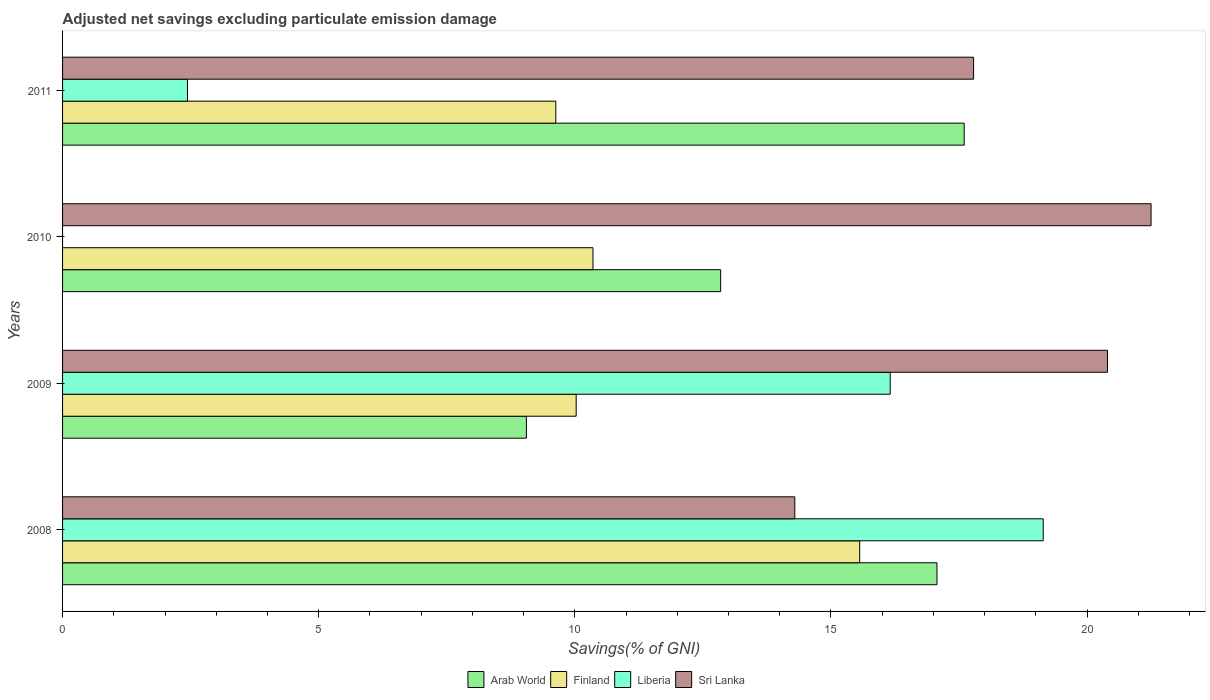Are the number of bars per tick equal to the number of legend labels?
Your response must be concise. No. Are the number of bars on each tick of the Y-axis equal?
Offer a very short reply. No. How many bars are there on the 4th tick from the top?
Offer a terse response. 4. What is the label of the 4th group of bars from the top?
Keep it short and to the point. 2008. What is the adjusted net savings in Arab World in 2011?
Offer a terse response. 17.6. Across all years, what is the maximum adjusted net savings in Arab World?
Make the answer very short. 17.6. In which year was the adjusted net savings in Liberia maximum?
Ensure brevity in your answer.  2008. What is the total adjusted net savings in Finland in the graph?
Make the answer very short. 45.57. What is the difference between the adjusted net savings in Arab World in 2009 and that in 2011?
Your answer should be compact. -8.55. What is the difference between the adjusted net savings in Arab World in 2010 and the adjusted net savings in Sri Lanka in 2008?
Your response must be concise. -1.45. What is the average adjusted net savings in Liberia per year?
Provide a short and direct response. 9.44. In the year 2010, what is the difference between the adjusted net savings in Finland and adjusted net savings in Sri Lanka?
Offer a terse response. -10.89. In how many years, is the adjusted net savings in Sri Lanka greater than 18 %?
Your answer should be compact. 2. What is the ratio of the adjusted net savings in Finland in 2008 to that in 2010?
Your answer should be very brief. 1.5. Is the difference between the adjusted net savings in Finland in 2008 and 2009 greater than the difference between the adjusted net savings in Sri Lanka in 2008 and 2009?
Your answer should be compact. Yes. What is the difference between the highest and the second highest adjusted net savings in Sri Lanka?
Provide a succinct answer. 0.85. What is the difference between the highest and the lowest adjusted net savings in Sri Lanka?
Provide a succinct answer. 6.96. In how many years, is the adjusted net savings in Liberia greater than the average adjusted net savings in Liberia taken over all years?
Give a very brief answer. 2. Is it the case that in every year, the sum of the adjusted net savings in Finland and adjusted net savings in Arab World is greater than the sum of adjusted net savings in Liberia and adjusted net savings in Sri Lanka?
Your answer should be very brief. No. Is it the case that in every year, the sum of the adjusted net savings in Arab World and adjusted net savings in Sri Lanka is greater than the adjusted net savings in Finland?
Provide a succinct answer. Yes. Are all the bars in the graph horizontal?
Provide a short and direct response. Yes. Are the values on the major ticks of X-axis written in scientific E-notation?
Your response must be concise. No. Does the graph contain any zero values?
Provide a short and direct response. Yes. How many legend labels are there?
Ensure brevity in your answer.  4. What is the title of the graph?
Your response must be concise. Adjusted net savings excluding particulate emission damage. Does "Tunisia" appear as one of the legend labels in the graph?
Give a very brief answer. No. What is the label or title of the X-axis?
Give a very brief answer. Savings(% of GNI). What is the label or title of the Y-axis?
Your answer should be compact. Years. What is the Savings(% of GNI) of Arab World in 2008?
Offer a very short reply. 17.07. What is the Savings(% of GNI) of Finland in 2008?
Make the answer very short. 15.56. What is the Savings(% of GNI) in Liberia in 2008?
Make the answer very short. 19.15. What is the Savings(% of GNI) of Sri Lanka in 2008?
Keep it short and to the point. 14.3. What is the Savings(% of GNI) in Arab World in 2009?
Give a very brief answer. 9.06. What is the Savings(% of GNI) of Finland in 2009?
Offer a very short reply. 10.03. What is the Savings(% of GNI) in Liberia in 2009?
Make the answer very short. 16.16. What is the Savings(% of GNI) in Sri Lanka in 2009?
Make the answer very short. 20.4. What is the Savings(% of GNI) of Arab World in 2010?
Your answer should be compact. 12.85. What is the Savings(% of GNI) of Finland in 2010?
Provide a succinct answer. 10.36. What is the Savings(% of GNI) of Sri Lanka in 2010?
Provide a succinct answer. 21.25. What is the Savings(% of GNI) of Arab World in 2011?
Provide a short and direct response. 17.6. What is the Savings(% of GNI) of Finland in 2011?
Your answer should be compact. 9.63. What is the Savings(% of GNI) of Liberia in 2011?
Provide a succinct answer. 2.44. What is the Savings(% of GNI) in Sri Lanka in 2011?
Your response must be concise. 17.79. Across all years, what is the maximum Savings(% of GNI) of Arab World?
Your response must be concise. 17.6. Across all years, what is the maximum Savings(% of GNI) in Finland?
Offer a very short reply. 15.56. Across all years, what is the maximum Savings(% of GNI) of Liberia?
Make the answer very short. 19.15. Across all years, what is the maximum Savings(% of GNI) in Sri Lanka?
Your answer should be compact. 21.25. Across all years, what is the minimum Savings(% of GNI) in Arab World?
Your response must be concise. 9.06. Across all years, what is the minimum Savings(% of GNI) of Finland?
Offer a terse response. 9.63. Across all years, what is the minimum Savings(% of GNI) in Liberia?
Keep it short and to the point. 0. Across all years, what is the minimum Savings(% of GNI) of Sri Lanka?
Your answer should be very brief. 14.3. What is the total Savings(% of GNI) in Arab World in the graph?
Make the answer very short. 56.58. What is the total Savings(% of GNI) in Finland in the graph?
Make the answer very short. 45.57. What is the total Savings(% of GNI) of Liberia in the graph?
Ensure brevity in your answer.  37.74. What is the total Savings(% of GNI) of Sri Lanka in the graph?
Ensure brevity in your answer.  73.73. What is the difference between the Savings(% of GNI) in Arab World in 2008 and that in 2009?
Provide a succinct answer. 8.02. What is the difference between the Savings(% of GNI) in Finland in 2008 and that in 2009?
Provide a short and direct response. 5.54. What is the difference between the Savings(% of GNI) of Liberia in 2008 and that in 2009?
Offer a very short reply. 2.99. What is the difference between the Savings(% of GNI) of Sri Lanka in 2008 and that in 2009?
Your answer should be compact. -6.1. What is the difference between the Savings(% of GNI) in Arab World in 2008 and that in 2010?
Your answer should be very brief. 4.22. What is the difference between the Savings(% of GNI) of Finland in 2008 and that in 2010?
Make the answer very short. 5.21. What is the difference between the Savings(% of GNI) in Sri Lanka in 2008 and that in 2010?
Provide a succinct answer. -6.96. What is the difference between the Savings(% of GNI) of Arab World in 2008 and that in 2011?
Give a very brief answer. -0.53. What is the difference between the Savings(% of GNI) of Finland in 2008 and that in 2011?
Your answer should be compact. 5.93. What is the difference between the Savings(% of GNI) of Liberia in 2008 and that in 2011?
Your response must be concise. 16.71. What is the difference between the Savings(% of GNI) in Sri Lanka in 2008 and that in 2011?
Provide a succinct answer. -3.49. What is the difference between the Savings(% of GNI) of Arab World in 2009 and that in 2010?
Give a very brief answer. -3.79. What is the difference between the Savings(% of GNI) in Finland in 2009 and that in 2010?
Your answer should be very brief. -0.33. What is the difference between the Savings(% of GNI) in Sri Lanka in 2009 and that in 2010?
Your response must be concise. -0.85. What is the difference between the Savings(% of GNI) of Arab World in 2009 and that in 2011?
Offer a terse response. -8.55. What is the difference between the Savings(% of GNI) in Finland in 2009 and that in 2011?
Keep it short and to the point. 0.4. What is the difference between the Savings(% of GNI) of Liberia in 2009 and that in 2011?
Ensure brevity in your answer.  13.72. What is the difference between the Savings(% of GNI) in Sri Lanka in 2009 and that in 2011?
Provide a short and direct response. 2.61. What is the difference between the Savings(% of GNI) in Arab World in 2010 and that in 2011?
Keep it short and to the point. -4.75. What is the difference between the Savings(% of GNI) in Finland in 2010 and that in 2011?
Your answer should be compact. 0.73. What is the difference between the Savings(% of GNI) in Sri Lanka in 2010 and that in 2011?
Keep it short and to the point. 3.47. What is the difference between the Savings(% of GNI) in Arab World in 2008 and the Savings(% of GNI) in Finland in 2009?
Ensure brevity in your answer.  7.04. What is the difference between the Savings(% of GNI) of Arab World in 2008 and the Savings(% of GNI) of Liberia in 2009?
Offer a very short reply. 0.91. What is the difference between the Savings(% of GNI) of Arab World in 2008 and the Savings(% of GNI) of Sri Lanka in 2009?
Offer a terse response. -3.33. What is the difference between the Savings(% of GNI) in Finland in 2008 and the Savings(% of GNI) in Liberia in 2009?
Offer a very short reply. -0.6. What is the difference between the Savings(% of GNI) of Finland in 2008 and the Savings(% of GNI) of Sri Lanka in 2009?
Offer a very short reply. -4.84. What is the difference between the Savings(% of GNI) in Liberia in 2008 and the Savings(% of GNI) in Sri Lanka in 2009?
Give a very brief answer. -1.25. What is the difference between the Savings(% of GNI) in Arab World in 2008 and the Savings(% of GNI) in Finland in 2010?
Provide a succinct answer. 6.72. What is the difference between the Savings(% of GNI) of Arab World in 2008 and the Savings(% of GNI) of Sri Lanka in 2010?
Offer a terse response. -4.18. What is the difference between the Savings(% of GNI) of Finland in 2008 and the Savings(% of GNI) of Sri Lanka in 2010?
Your response must be concise. -5.69. What is the difference between the Savings(% of GNI) in Liberia in 2008 and the Savings(% of GNI) in Sri Lanka in 2010?
Ensure brevity in your answer.  -2.11. What is the difference between the Savings(% of GNI) of Arab World in 2008 and the Savings(% of GNI) of Finland in 2011?
Your response must be concise. 7.44. What is the difference between the Savings(% of GNI) in Arab World in 2008 and the Savings(% of GNI) in Liberia in 2011?
Offer a terse response. 14.63. What is the difference between the Savings(% of GNI) of Arab World in 2008 and the Savings(% of GNI) of Sri Lanka in 2011?
Keep it short and to the point. -0.71. What is the difference between the Savings(% of GNI) of Finland in 2008 and the Savings(% of GNI) of Liberia in 2011?
Give a very brief answer. 13.12. What is the difference between the Savings(% of GNI) in Finland in 2008 and the Savings(% of GNI) in Sri Lanka in 2011?
Provide a short and direct response. -2.22. What is the difference between the Savings(% of GNI) in Liberia in 2008 and the Savings(% of GNI) in Sri Lanka in 2011?
Ensure brevity in your answer.  1.36. What is the difference between the Savings(% of GNI) in Arab World in 2009 and the Savings(% of GNI) in Finland in 2010?
Your response must be concise. -1.3. What is the difference between the Savings(% of GNI) in Arab World in 2009 and the Savings(% of GNI) in Sri Lanka in 2010?
Keep it short and to the point. -12.2. What is the difference between the Savings(% of GNI) in Finland in 2009 and the Savings(% of GNI) in Sri Lanka in 2010?
Your answer should be very brief. -11.22. What is the difference between the Savings(% of GNI) of Liberia in 2009 and the Savings(% of GNI) of Sri Lanka in 2010?
Offer a very short reply. -5.09. What is the difference between the Savings(% of GNI) in Arab World in 2009 and the Savings(% of GNI) in Finland in 2011?
Offer a very short reply. -0.57. What is the difference between the Savings(% of GNI) of Arab World in 2009 and the Savings(% of GNI) of Liberia in 2011?
Your response must be concise. 6.62. What is the difference between the Savings(% of GNI) of Arab World in 2009 and the Savings(% of GNI) of Sri Lanka in 2011?
Make the answer very short. -8.73. What is the difference between the Savings(% of GNI) of Finland in 2009 and the Savings(% of GNI) of Liberia in 2011?
Make the answer very short. 7.59. What is the difference between the Savings(% of GNI) of Finland in 2009 and the Savings(% of GNI) of Sri Lanka in 2011?
Offer a very short reply. -7.76. What is the difference between the Savings(% of GNI) in Liberia in 2009 and the Savings(% of GNI) in Sri Lanka in 2011?
Provide a succinct answer. -1.63. What is the difference between the Savings(% of GNI) in Arab World in 2010 and the Savings(% of GNI) in Finland in 2011?
Ensure brevity in your answer.  3.22. What is the difference between the Savings(% of GNI) of Arab World in 2010 and the Savings(% of GNI) of Liberia in 2011?
Provide a succinct answer. 10.41. What is the difference between the Savings(% of GNI) of Arab World in 2010 and the Savings(% of GNI) of Sri Lanka in 2011?
Give a very brief answer. -4.94. What is the difference between the Savings(% of GNI) of Finland in 2010 and the Savings(% of GNI) of Liberia in 2011?
Offer a very short reply. 7.92. What is the difference between the Savings(% of GNI) in Finland in 2010 and the Savings(% of GNI) in Sri Lanka in 2011?
Ensure brevity in your answer.  -7.43. What is the average Savings(% of GNI) of Arab World per year?
Offer a very short reply. 14.14. What is the average Savings(% of GNI) in Finland per year?
Your answer should be very brief. 11.39. What is the average Savings(% of GNI) in Liberia per year?
Give a very brief answer. 9.44. What is the average Savings(% of GNI) in Sri Lanka per year?
Your answer should be compact. 18.43. In the year 2008, what is the difference between the Savings(% of GNI) of Arab World and Savings(% of GNI) of Finland?
Make the answer very short. 1.51. In the year 2008, what is the difference between the Savings(% of GNI) in Arab World and Savings(% of GNI) in Liberia?
Ensure brevity in your answer.  -2.07. In the year 2008, what is the difference between the Savings(% of GNI) in Arab World and Savings(% of GNI) in Sri Lanka?
Provide a short and direct response. 2.78. In the year 2008, what is the difference between the Savings(% of GNI) in Finland and Savings(% of GNI) in Liberia?
Ensure brevity in your answer.  -3.58. In the year 2008, what is the difference between the Savings(% of GNI) of Finland and Savings(% of GNI) of Sri Lanka?
Your answer should be compact. 1.27. In the year 2008, what is the difference between the Savings(% of GNI) of Liberia and Savings(% of GNI) of Sri Lanka?
Provide a short and direct response. 4.85. In the year 2009, what is the difference between the Savings(% of GNI) in Arab World and Savings(% of GNI) in Finland?
Offer a very short reply. -0.97. In the year 2009, what is the difference between the Savings(% of GNI) of Arab World and Savings(% of GNI) of Liberia?
Your answer should be compact. -7.1. In the year 2009, what is the difference between the Savings(% of GNI) of Arab World and Savings(% of GNI) of Sri Lanka?
Provide a succinct answer. -11.34. In the year 2009, what is the difference between the Savings(% of GNI) of Finland and Savings(% of GNI) of Liberia?
Your answer should be compact. -6.13. In the year 2009, what is the difference between the Savings(% of GNI) of Finland and Savings(% of GNI) of Sri Lanka?
Make the answer very short. -10.37. In the year 2009, what is the difference between the Savings(% of GNI) in Liberia and Savings(% of GNI) in Sri Lanka?
Your answer should be very brief. -4.24. In the year 2010, what is the difference between the Savings(% of GNI) of Arab World and Savings(% of GNI) of Finland?
Give a very brief answer. 2.49. In the year 2010, what is the difference between the Savings(% of GNI) in Arab World and Savings(% of GNI) in Sri Lanka?
Keep it short and to the point. -8.4. In the year 2010, what is the difference between the Savings(% of GNI) in Finland and Savings(% of GNI) in Sri Lanka?
Offer a terse response. -10.89. In the year 2011, what is the difference between the Savings(% of GNI) of Arab World and Savings(% of GNI) of Finland?
Your response must be concise. 7.97. In the year 2011, what is the difference between the Savings(% of GNI) of Arab World and Savings(% of GNI) of Liberia?
Your answer should be very brief. 15.16. In the year 2011, what is the difference between the Savings(% of GNI) in Arab World and Savings(% of GNI) in Sri Lanka?
Provide a succinct answer. -0.18. In the year 2011, what is the difference between the Savings(% of GNI) in Finland and Savings(% of GNI) in Liberia?
Offer a very short reply. 7.19. In the year 2011, what is the difference between the Savings(% of GNI) of Finland and Savings(% of GNI) of Sri Lanka?
Offer a terse response. -8.16. In the year 2011, what is the difference between the Savings(% of GNI) in Liberia and Savings(% of GNI) in Sri Lanka?
Make the answer very short. -15.35. What is the ratio of the Savings(% of GNI) in Arab World in 2008 to that in 2009?
Make the answer very short. 1.89. What is the ratio of the Savings(% of GNI) in Finland in 2008 to that in 2009?
Keep it short and to the point. 1.55. What is the ratio of the Savings(% of GNI) of Liberia in 2008 to that in 2009?
Provide a short and direct response. 1.18. What is the ratio of the Savings(% of GNI) in Sri Lanka in 2008 to that in 2009?
Your answer should be very brief. 0.7. What is the ratio of the Savings(% of GNI) in Arab World in 2008 to that in 2010?
Your answer should be very brief. 1.33. What is the ratio of the Savings(% of GNI) in Finland in 2008 to that in 2010?
Ensure brevity in your answer.  1.5. What is the ratio of the Savings(% of GNI) in Sri Lanka in 2008 to that in 2010?
Provide a succinct answer. 0.67. What is the ratio of the Savings(% of GNI) in Arab World in 2008 to that in 2011?
Your answer should be compact. 0.97. What is the ratio of the Savings(% of GNI) in Finland in 2008 to that in 2011?
Your response must be concise. 1.62. What is the ratio of the Savings(% of GNI) in Liberia in 2008 to that in 2011?
Provide a short and direct response. 7.85. What is the ratio of the Savings(% of GNI) of Sri Lanka in 2008 to that in 2011?
Ensure brevity in your answer.  0.8. What is the ratio of the Savings(% of GNI) of Arab World in 2009 to that in 2010?
Offer a terse response. 0.7. What is the ratio of the Savings(% of GNI) in Finland in 2009 to that in 2010?
Ensure brevity in your answer.  0.97. What is the ratio of the Savings(% of GNI) of Sri Lanka in 2009 to that in 2010?
Provide a succinct answer. 0.96. What is the ratio of the Savings(% of GNI) of Arab World in 2009 to that in 2011?
Your response must be concise. 0.51. What is the ratio of the Savings(% of GNI) of Finland in 2009 to that in 2011?
Offer a terse response. 1.04. What is the ratio of the Savings(% of GNI) in Liberia in 2009 to that in 2011?
Make the answer very short. 6.63. What is the ratio of the Savings(% of GNI) in Sri Lanka in 2009 to that in 2011?
Provide a succinct answer. 1.15. What is the ratio of the Savings(% of GNI) in Arab World in 2010 to that in 2011?
Make the answer very short. 0.73. What is the ratio of the Savings(% of GNI) of Finland in 2010 to that in 2011?
Keep it short and to the point. 1.08. What is the ratio of the Savings(% of GNI) of Sri Lanka in 2010 to that in 2011?
Make the answer very short. 1.19. What is the difference between the highest and the second highest Savings(% of GNI) in Arab World?
Your response must be concise. 0.53. What is the difference between the highest and the second highest Savings(% of GNI) in Finland?
Your response must be concise. 5.21. What is the difference between the highest and the second highest Savings(% of GNI) in Liberia?
Offer a very short reply. 2.99. What is the difference between the highest and the second highest Savings(% of GNI) of Sri Lanka?
Provide a short and direct response. 0.85. What is the difference between the highest and the lowest Savings(% of GNI) in Arab World?
Offer a very short reply. 8.55. What is the difference between the highest and the lowest Savings(% of GNI) of Finland?
Offer a very short reply. 5.93. What is the difference between the highest and the lowest Savings(% of GNI) of Liberia?
Your answer should be compact. 19.15. What is the difference between the highest and the lowest Savings(% of GNI) of Sri Lanka?
Offer a terse response. 6.96. 